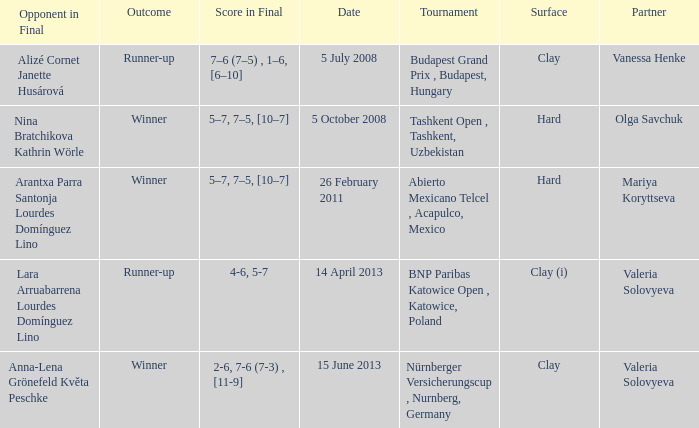Name the outcome for alizé cornet janette husárová being opponent in final Runner-up. 